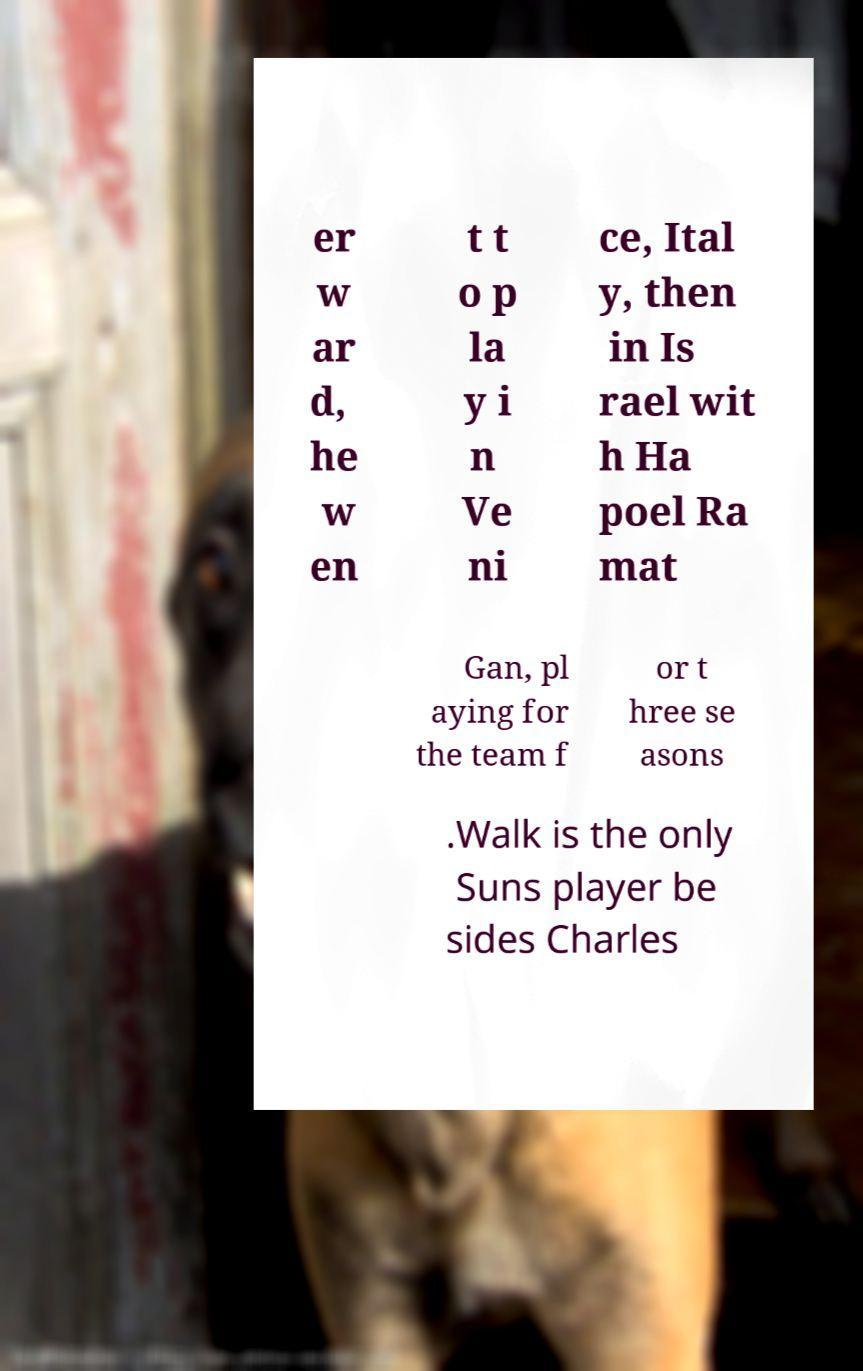Could you extract and type out the text from this image? er w ar d, he w en t t o p la y i n Ve ni ce, Ital y, then in Is rael wit h Ha poel Ra mat Gan, pl aying for the team f or t hree se asons .Walk is the only Suns player be sides Charles 